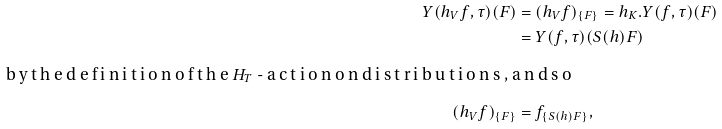<formula> <loc_0><loc_0><loc_500><loc_500>Y ( h _ { V } f , \tau ) ( F ) & = ( h _ { V } f ) _ { \{ F \} } = h _ { K } . Y ( f , \tau ) ( F ) \\ & = Y ( f , \tau ) ( S ( h ) F ) \intertext { b y t h e d e f i n i t i o n o f t h e $ H _ { T } $ - a c t i o n o n d i s t r i b u t i o n s , a n d s o } ( h _ { V } f ) _ { \{ F \} } & = f _ { \{ S ( h ) F \} } ,</formula> 